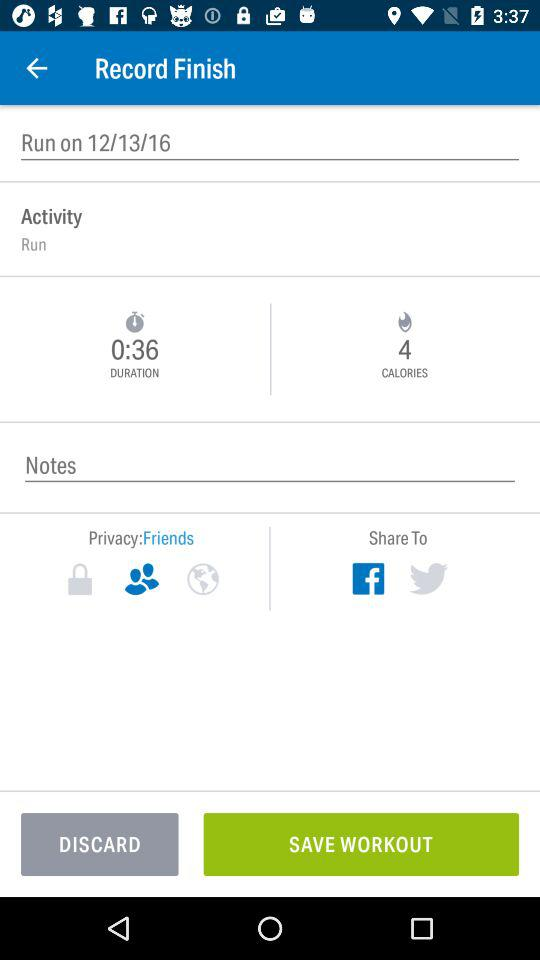Which applications can be used to share? The applications that can be used to share are "Facebook" and "Twitter". 